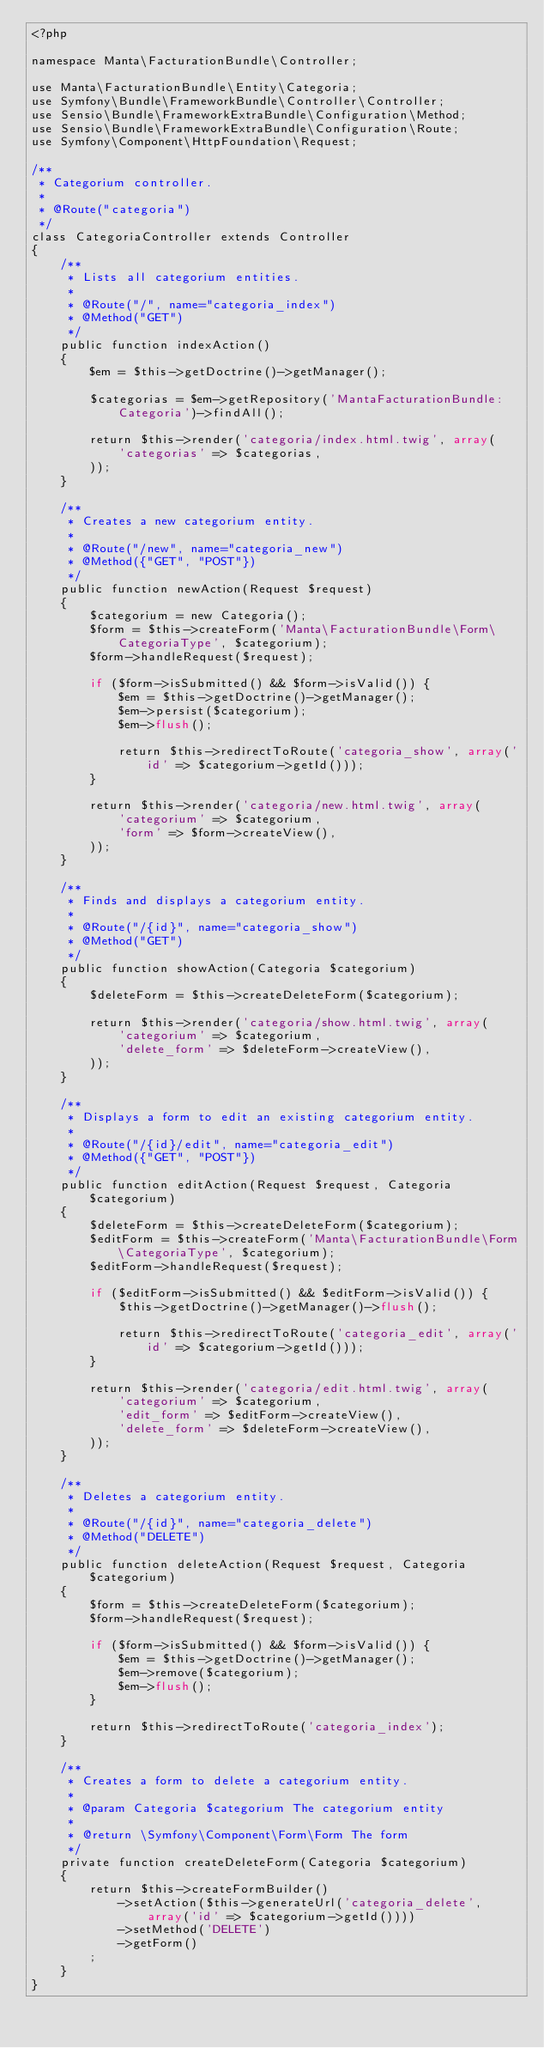<code> <loc_0><loc_0><loc_500><loc_500><_PHP_><?php

namespace Manta\FacturationBundle\Controller;

use Manta\FacturationBundle\Entity\Categoria;
use Symfony\Bundle\FrameworkBundle\Controller\Controller;
use Sensio\Bundle\FrameworkExtraBundle\Configuration\Method;
use Sensio\Bundle\FrameworkExtraBundle\Configuration\Route;
use Symfony\Component\HttpFoundation\Request;

/**
 * Categorium controller.
 *
 * @Route("categoria")
 */
class CategoriaController extends Controller
{
    /**
     * Lists all categorium entities.
     *
     * @Route("/", name="categoria_index")
     * @Method("GET")
     */
    public function indexAction()
    {
        $em = $this->getDoctrine()->getManager();

        $categorias = $em->getRepository('MantaFacturationBundle:Categoria')->findAll();

        return $this->render('categoria/index.html.twig', array(
            'categorias' => $categorias,
        ));
    }

    /**
     * Creates a new categorium entity.
     *
     * @Route("/new", name="categoria_new")
     * @Method({"GET", "POST"})
     */
    public function newAction(Request $request)
    {
        $categorium = new Categoria();
        $form = $this->createForm('Manta\FacturationBundle\Form\CategoriaType', $categorium);
        $form->handleRequest($request);

        if ($form->isSubmitted() && $form->isValid()) {
            $em = $this->getDoctrine()->getManager();
            $em->persist($categorium);
            $em->flush();

            return $this->redirectToRoute('categoria_show', array('id' => $categorium->getId()));
        }

        return $this->render('categoria/new.html.twig', array(
            'categorium' => $categorium,
            'form' => $form->createView(),
        ));
    }

    /**
     * Finds and displays a categorium entity.
     *
     * @Route("/{id}", name="categoria_show")
     * @Method("GET")
     */
    public function showAction(Categoria $categorium)
    {
        $deleteForm = $this->createDeleteForm($categorium);

        return $this->render('categoria/show.html.twig', array(
            'categorium' => $categorium,
            'delete_form' => $deleteForm->createView(),
        ));
    }

    /**
     * Displays a form to edit an existing categorium entity.
     *
     * @Route("/{id}/edit", name="categoria_edit")
     * @Method({"GET", "POST"})
     */
    public function editAction(Request $request, Categoria $categorium)
    {
        $deleteForm = $this->createDeleteForm($categorium);
        $editForm = $this->createForm('Manta\FacturationBundle\Form\CategoriaType', $categorium);
        $editForm->handleRequest($request);

        if ($editForm->isSubmitted() && $editForm->isValid()) {
            $this->getDoctrine()->getManager()->flush();

            return $this->redirectToRoute('categoria_edit', array('id' => $categorium->getId()));
        }

        return $this->render('categoria/edit.html.twig', array(
            'categorium' => $categorium,
            'edit_form' => $editForm->createView(),
            'delete_form' => $deleteForm->createView(),
        ));
    }

    /**
     * Deletes a categorium entity.
     *
     * @Route("/{id}", name="categoria_delete")
     * @Method("DELETE")
     */
    public function deleteAction(Request $request, Categoria $categorium)
    {
        $form = $this->createDeleteForm($categorium);
        $form->handleRequest($request);

        if ($form->isSubmitted() && $form->isValid()) {
            $em = $this->getDoctrine()->getManager();
            $em->remove($categorium);
            $em->flush();
        }

        return $this->redirectToRoute('categoria_index');
    }

    /**
     * Creates a form to delete a categorium entity.
     *
     * @param Categoria $categorium The categorium entity
     *
     * @return \Symfony\Component\Form\Form The form
     */
    private function createDeleteForm(Categoria $categorium)
    {
        return $this->createFormBuilder()
            ->setAction($this->generateUrl('categoria_delete', array('id' => $categorium->getId())))
            ->setMethod('DELETE')
            ->getForm()
        ;
    }
}
</code> 